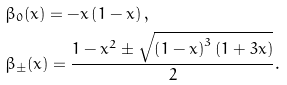Convert formula to latex. <formula><loc_0><loc_0><loc_500><loc_500>& \beta _ { 0 } ( x ) = - x \left ( 1 - x \right ) , \\ & \beta _ { \pm } ( x ) = \frac { 1 - x ^ { 2 } \pm \sqrt { \left ( 1 - x \right ) ^ { 3 } \left ( 1 + 3 x \right ) } } { 2 } .</formula> 